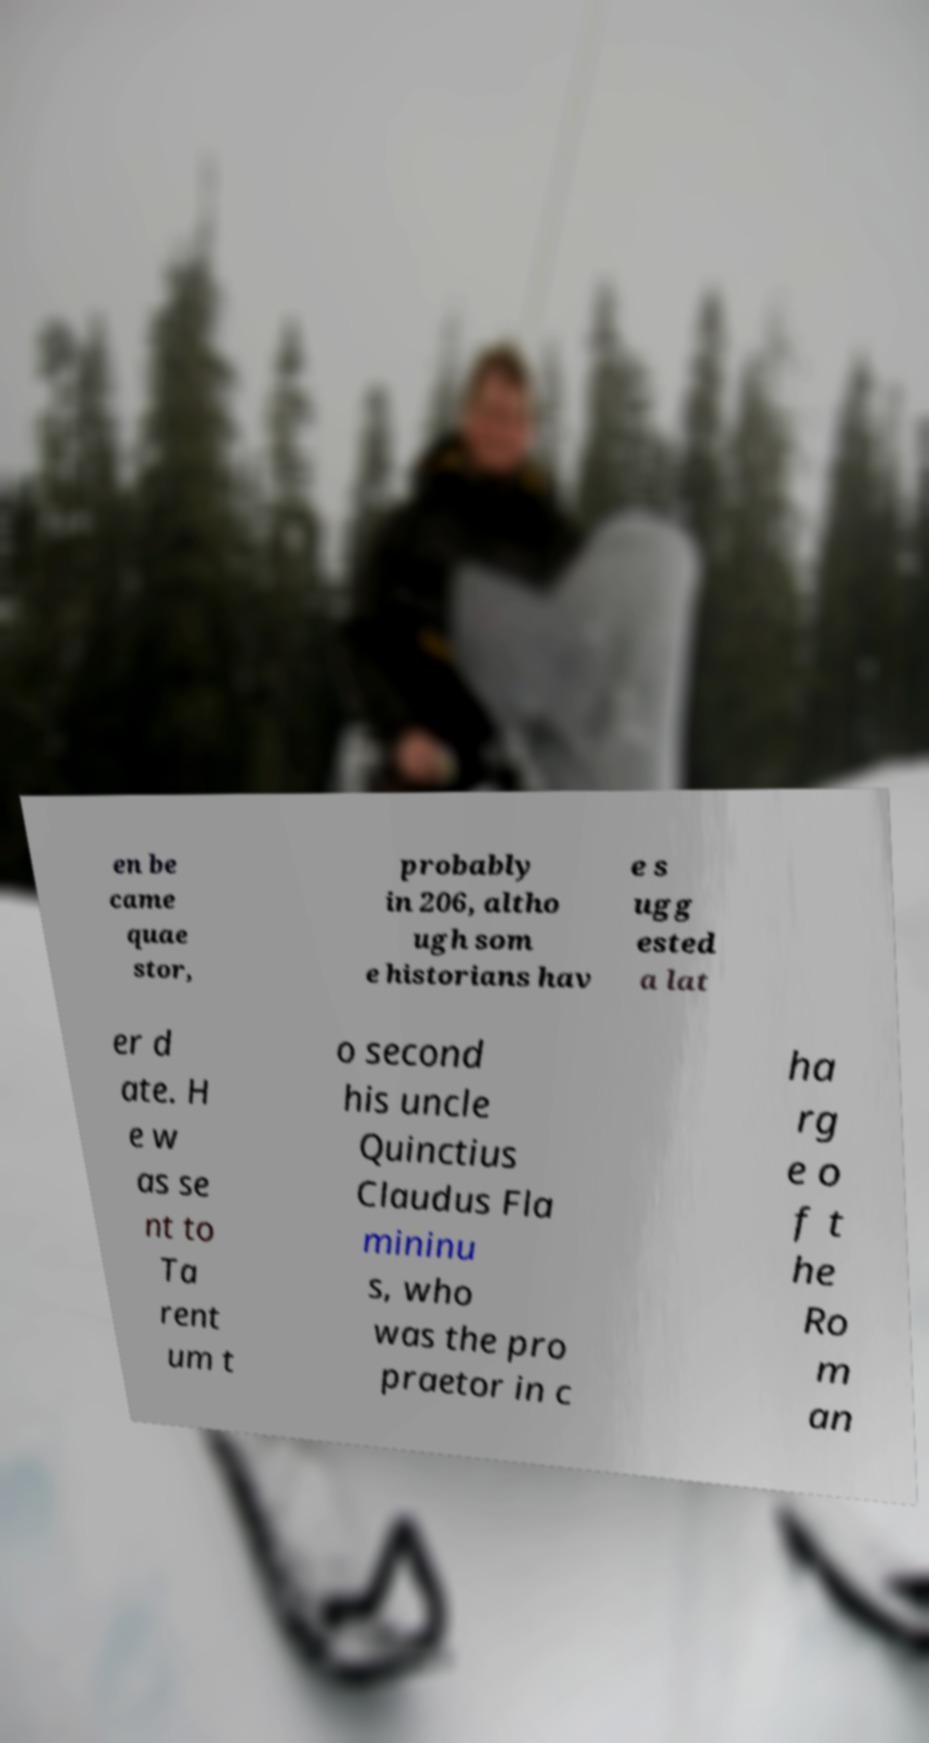There's text embedded in this image that I need extracted. Can you transcribe it verbatim? en be came quae stor, probably in 206, altho ugh som e historians hav e s ugg ested a lat er d ate. H e w as se nt to Ta rent um t o second his uncle Quinctius Claudus Fla mininu s, who was the pro praetor in c ha rg e o f t he Ro m an 